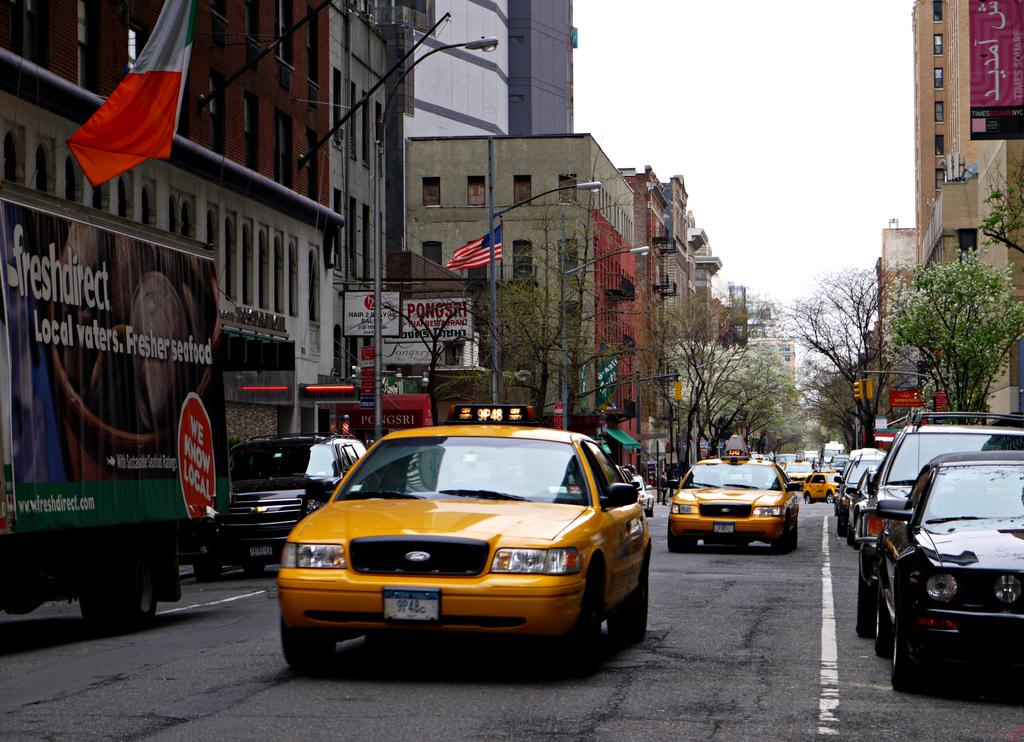<image>
Describe the image concisely. A taxi is driving down the street past a Fresh Direct truck 